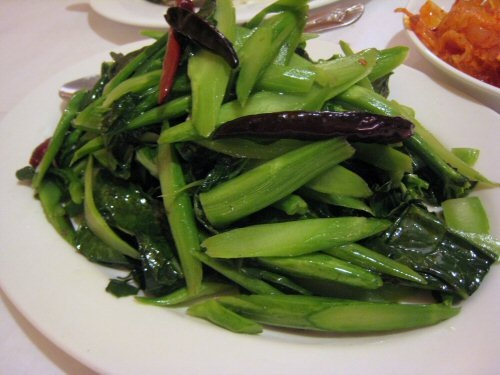Describe the objects in this image and their specific colors. I can see dining table in darkgray, lightgray, and gray tones and bowl in darkgray, brown, maroon, and gray tones in this image. 